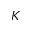Convert formula to latex. <formula><loc_0><loc_0><loc_500><loc_500>K</formula> 